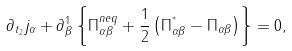Convert formula to latex. <formula><loc_0><loc_0><loc_500><loc_500>\partial _ { t _ { 2 } } j _ { \alpha } + \partial _ { \beta } ^ { 1 } \left \{ \Pi _ { \alpha \beta } ^ { n e q } + \frac { 1 } { 2 } \left ( \Pi _ { \alpha \beta } ^ { ^ { * } } - \Pi _ { \alpha \beta } \right ) \right \} = 0 ,</formula> 